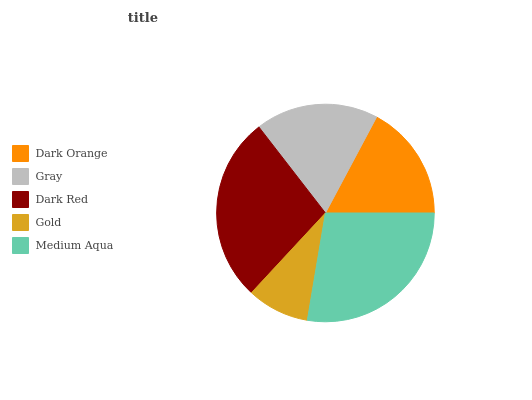Is Gold the minimum?
Answer yes or no. Yes. Is Medium Aqua the maximum?
Answer yes or no. Yes. Is Gray the minimum?
Answer yes or no. No. Is Gray the maximum?
Answer yes or no. No. Is Gray greater than Dark Orange?
Answer yes or no. Yes. Is Dark Orange less than Gray?
Answer yes or no. Yes. Is Dark Orange greater than Gray?
Answer yes or no. No. Is Gray less than Dark Orange?
Answer yes or no. No. Is Gray the high median?
Answer yes or no. Yes. Is Gray the low median?
Answer yes or no. Yes. Is Medium Aqua the high median?
Answer yes or no. No. Is Gold the low median?
Answer yes or no. No. 